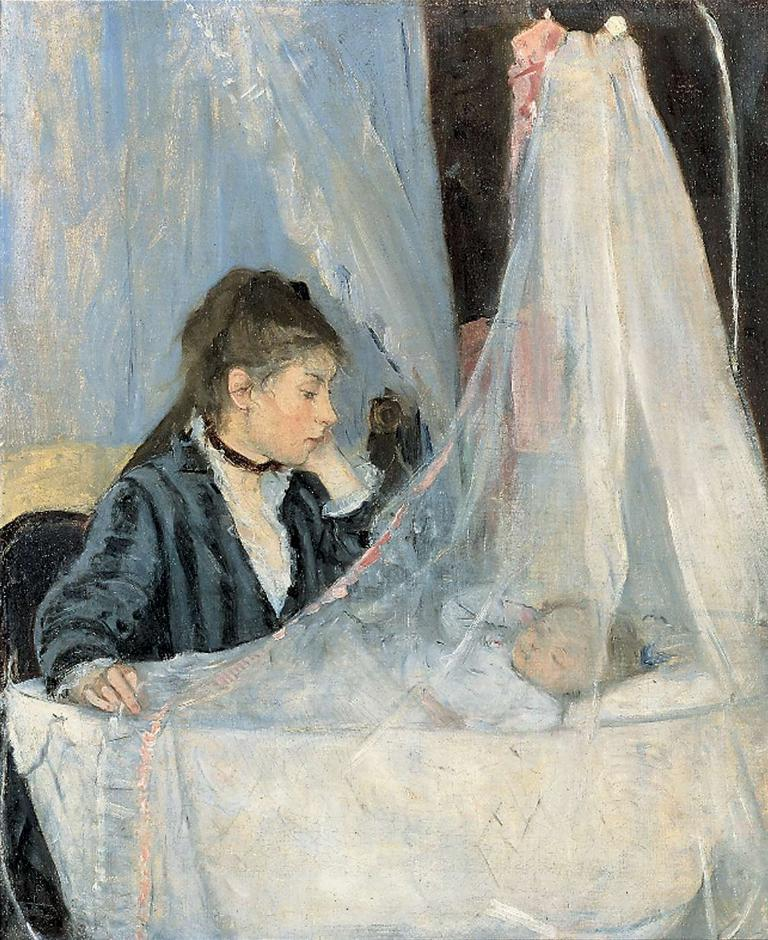What is depicted in the painting in the image? There is a painting of a person in the image. What can be seen in the image besides the painting? A baby is laying on a cradle in the image. What is the person in the painting holding or wearing? There is a cloth on the right side of the person in the painting. How many forks can be seen in the image? There are no forks present in the image. What is the baby doing with their foot in the image? The baby is laying on a cradle in the image and is not shown doing anything with their foot. 